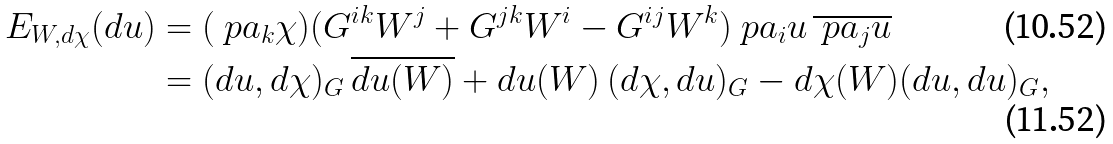Convert formula to latex. <formula><loc_0><loc_0><loc_500><loc_500>E _ { W , d \chi } ( d u ) & = ( \ p a _ { k } \chi ) ( G ^ { i k } W ^ { j } + G ^ { j k } W ^ { i } - G ^ { i j } W ^ { k } ) \ p a _ { i } u \, \overline { \ p a _ { j } u } \\ & = ( d u , d \chi ) _ { G } \, \overline { d u ( W ) } + d u ( W ) \, ( d \chi , d u ) _ { G } - d \chi ( W ) ( d u , d u ) _ { G } ,</formula> 